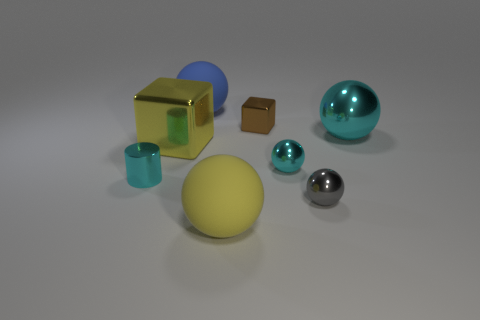Is the number of large metal blocks right of the large cyan sphere the same as the number of large cyan spheres on the left side of the small brown shiny thing?
Make the answer very short. Yes. Is the size of the blue object to the right of the tiny cylinder the same as the cube that is in front of the brown shiny object?
Your answer should be compact. Yes. What is the shape of the yellow object that is on the left side of the large matte sphere behind the small gray metallic object that is in front of the tiny cyan cylinder?
Provide a short and direct response. Cube. Is there any other thing that is made of the same material as the large cyan ball?
Give a very brief answer. Yes. There is a yellow thing that is the same shape as the big cyan metal thing; what size is it?
Provide a short and direct response. Large. There is a large sphere that is in front of the large blue rubber sphere and to the left of the tiny shiny cube; what color is it?
Your answer should be very brief. Yellow. Do the small brown block and the yellow object that is behind the gray metallic object have the same material?
Ensure brevity in your answer.  Yes. Are there fewer tiny cyan things that are left of the small cyan metallic cylinder than tiny rubber objects?
Your answer should be very brief. No. What number of other things are the same shape as the gray shiny object?
Offer a terse response. 4. Are there any other things of the same color as the small shiny cube?
Your answer should be compact. No. 